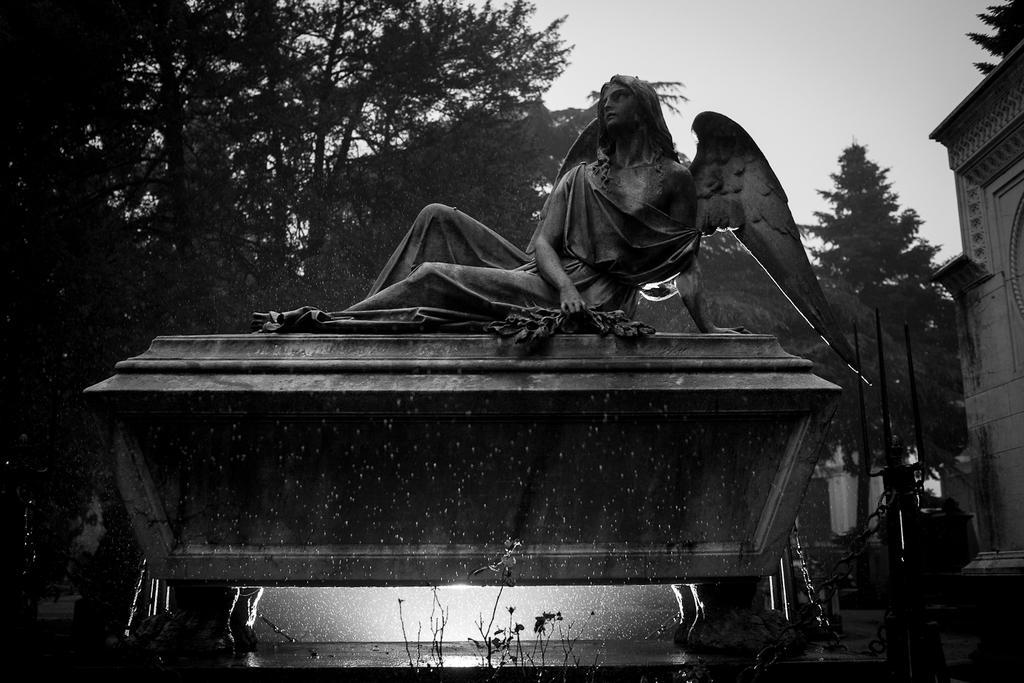How would you summarize this image in a sentence or two? The statue is highlighted in this picture. This statue has wings. Far there are number of trees. Sky is in white color. This picture is in black and white. This is a building in white color. 